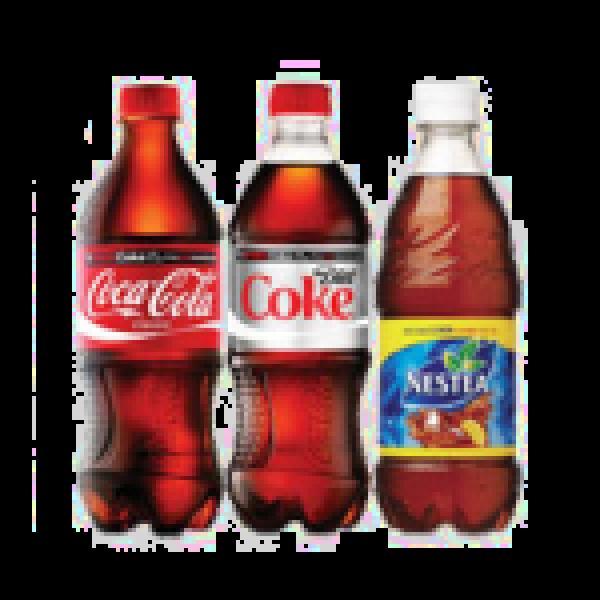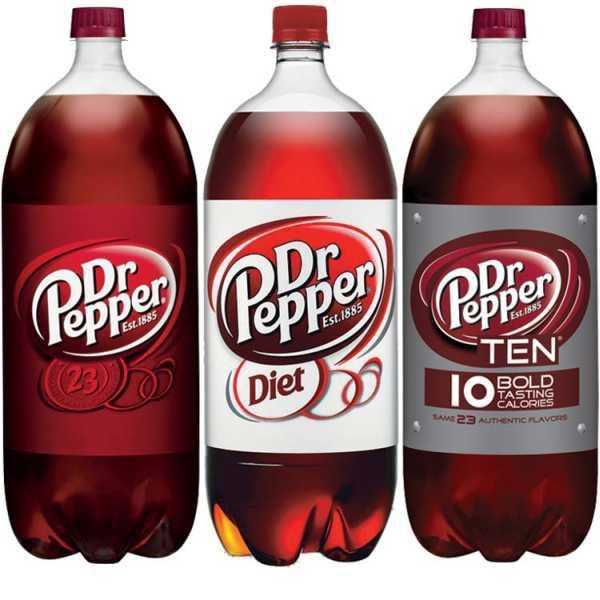The first image is the image on the left, the second image is the image on the right. For the images shown, is this caption "There are an odd number of sodas." true? Answer yes or no. No. The first image is the image on the left, the second image is the image on the right. Examine the images to the left and right. Is the description "There are at most six bottles in the image pair." accurate? Answer yes or no. Yes. 